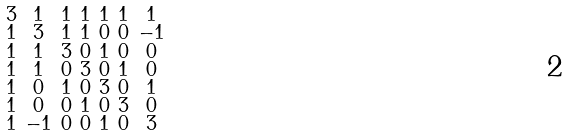<formula> <loc_0><loc_0><loc_500><loc_500>\begin{smallmatrix} 3 & 1 & 1 & 1 & 1 & 1 & 1 \\ 1 & 3 & 1 & 1 & 0 & 0 & - 1 \\ 1 & 1 & 3 & 0 & 1 & 0 & 0 \\ 1 & 1 & 0 & 3 & 0 & 1 & 0 \\ 1 & 0 & 1 & 0 & 3 & 0 & 1 \\ 1 & 0 & 0 & 1 & 0 & 3 & 0 \\ 1 & - 1 & 0 & 0 & 1 & 0 & 3 \end{smallmatrix}</formula> 